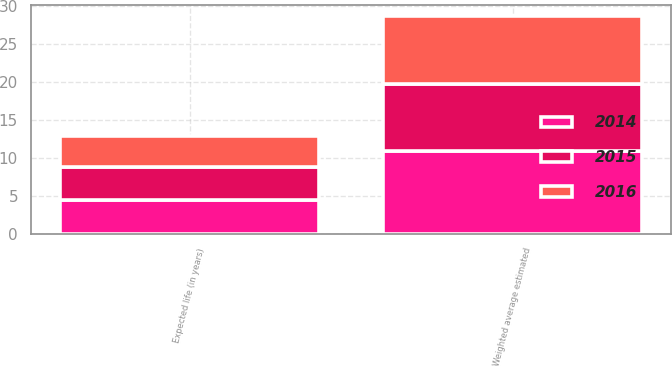Convert chart to OTSL. <chart><loc_0><loc_0><loc_500><loc_500><stacked_bar_chart><ecel><fcel>Expected life (in years)<fcel>Weighted average estimated<nl><fcel>2016<fcel>4.1<fcel>8.97<nl><fcel>2015<fcel>4.3<fcel>8.77<nl><fcel>2014<fcel>4.5<fcel>10.95<nl></chart> 